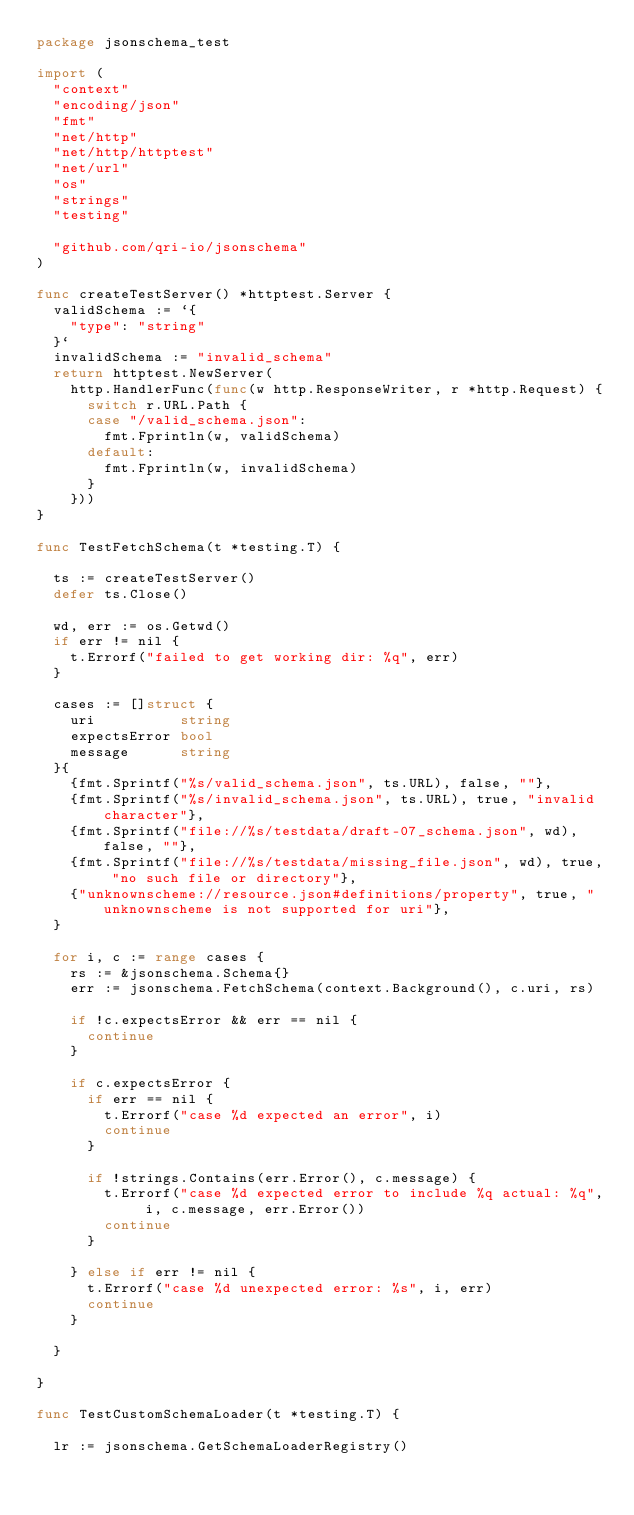<code> <loc_0><loc_0><loc_500><loc_500><_Go_>package jsonschema_test

import (
	"context"
	"encoding/json"
	"fmt"
	"net/http"
	"net/http/httptest"
	"net/url"
	"os"
	"strings"
	"testing"

	"github.com/qri-io/jsonschema"
)

func createTestServer() *httptest.Server {
	validSchema := `{
		"type": "string"
	}`
	invalidSchema := "invalid_schema"
	return httptest.NewServer(
		http.HandlerFunc(func(w http.ResponseWriter, r *http.Request) {
			switch r.URL.Path {
			case "/valid_schema.json":
				fmt.Fprintln(w, validSchema)
			default:
				fmt.Fprintln(w, invalidSchema)
			}
		}))
}

func TestFetchSchema(t *testing.T) {

	ts := createTestServer()
	defer ts.Close()

	wd, err := os.Getwd()
	if err != nil {
		t.Errorf("failed to get working dir: %q", err)
	}

	cases := []struct {
		uri          string
		expectsError bool
		message      string
	}{
		{fmt.Sprintf("%s/valid_schema.json", ts.URL), false, ""},
		{fmt.Sprintf("%s/invalid_schema.json", ts.URL), true, "invalid character"},
		{fmt.Sprintf("file://%s/testdata/draft-07_schema.json", wd), false, ""},
		{fmt.Sprintf("file://%s/testdata/missing_file.json", wd), true, "no such file or directory"},
		{"unknownscheme://resource.json#definitions/property", true, "unknownscheme is not supported for uri"},
	}

	for i, c := range cases {
		rs := &jsonschema.Schema{}
		err := jsonschema.FetchSchema(context.Background(), c.uri, rs)

		if !c.expectsError && err == nil {
			continue
		}

		if c.expectsError {
			if err == nil {
				t.Errorf("case %d expected an error", i)
				continue
			}

			if !strings.Contains(err.Error(), c.message) {
				t.Errorf("case %d expected error to include %q actual: %q", i, c.message, err.Error())
				continue
			}

		} else if err != nil {
			t.Errorf("case %d unexpected error: %s", i, err)
			continue
		}

	}

}

func TestCustomSchemaLoader(t *testing.T) {

	lr := jsonschema.GetSchemaLoaderRegistry()</code> 